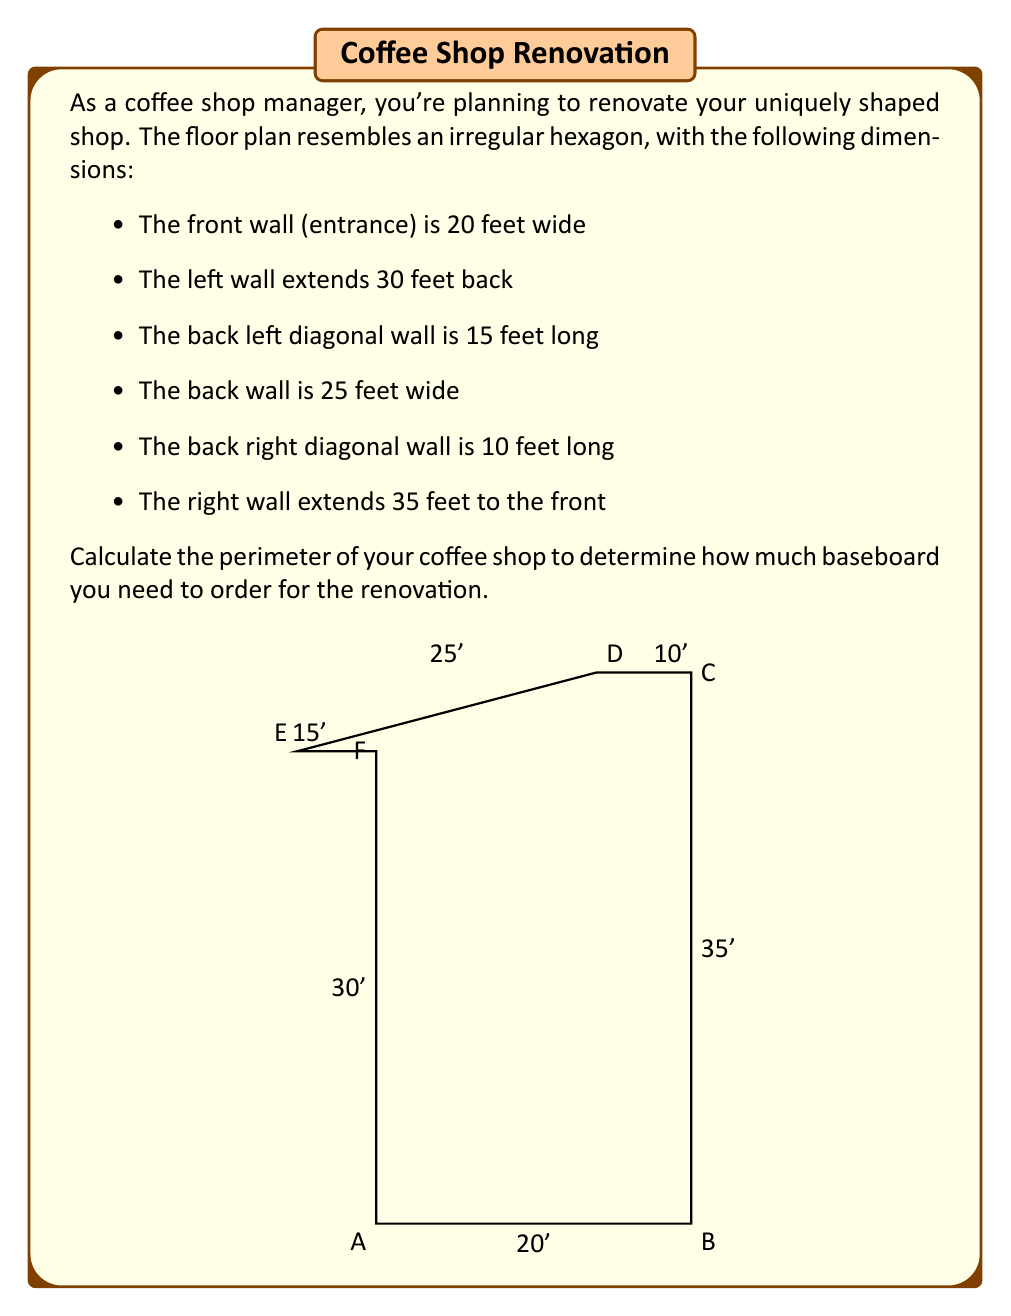What is the answer to this math problem? To calculate the perimeter of the coffee shop, we need to add up the lengths of all sides. Let's break it down step by step:

1) Front wall (entrance): 20 feet
2) Right wall: 35 feet
3) Back right diagonal: 10 feet
4) Back wall: 25 feet
5) Back left diagonal: 15 feet
6) Left wall: 30 feet

Now, let's add these lengths:

$$\text{Perimeter} = 20 + 35 + 10 + 25 + 15 + 30$$

$$\text{Perimeter} = 135 \text{ feet}$$

Therefore, the total perimeter of the coffee shop is 135 feet. This is the amount of baseboard you'll need to order for your renovation, plus a little extra to account for cuts and waste.
Answer: The perimeter of the coffee shop is 135 feet. 